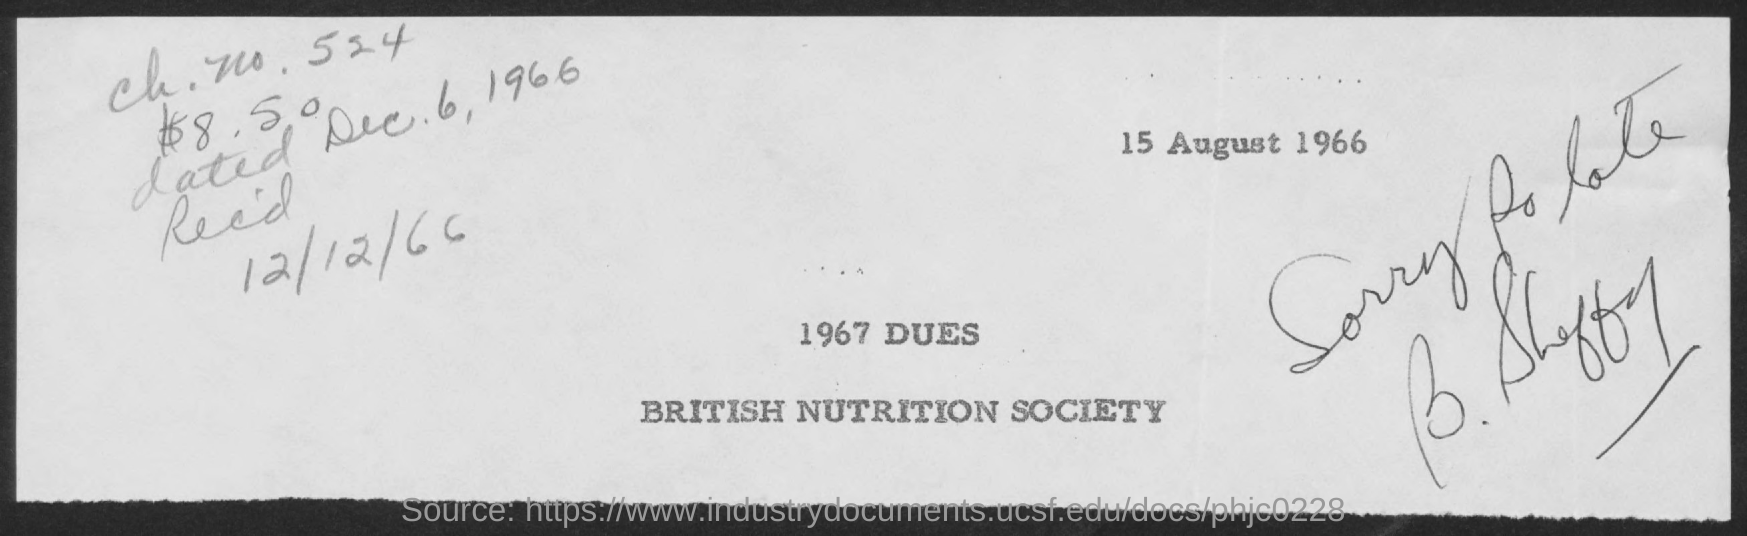Highlight a few significant elements in this photo. The received date given in this document is December 12, 1966. 